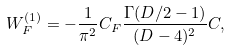<formula> <loc_0><loc_0><loc_500><loc_500>W _ { F } ^ { ( 1 ) } = - \frac { 1 } { \pi ^ { 2 } } C _ { F } \frac { \Gamma ( D / 2 - 1 ) } { ( D - 4 ) ^ { 2 } } C ,</formula> 